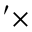<formula> <loc_0><loc_0><loc_500><loc_500>^ { \prime } \times</formula> 